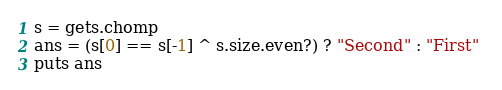Convert code to text. <code><loc_0><loc_0><loc_500><loc_500><_Ruby_>s = gets.chomp
ans = (s[0] == s[-1] ^ s.size.even?) ? "Second" : "First" 
puts ans</code> 